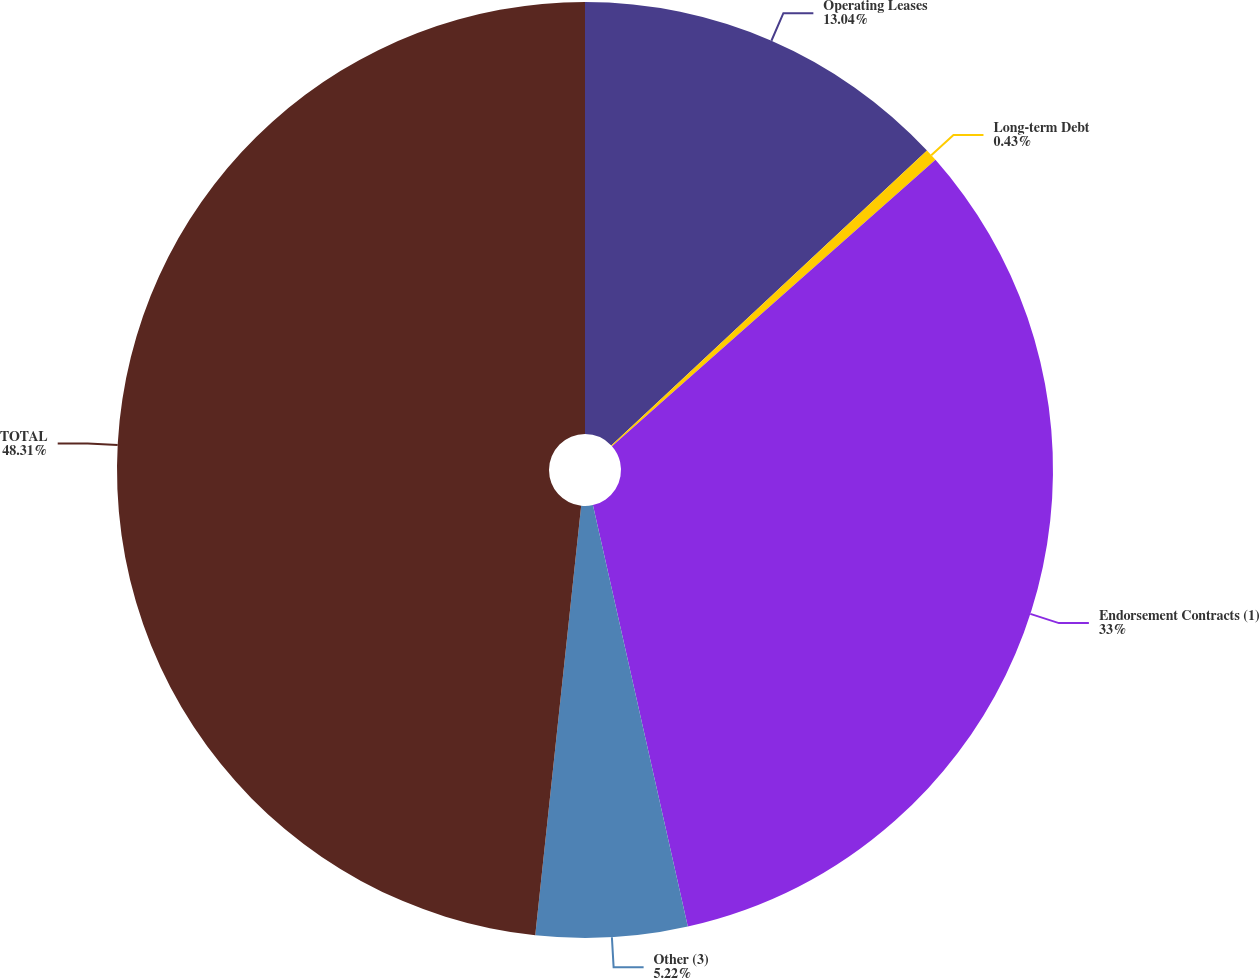Convert chart. <chart><loc_0><loc_0><loc_500><loc_500><pie_chart><fcel>Operating Leases<fcel>Long-term Debt<fcel>Endorsement Contracts (1)<fcel>Other (3)<fcel>TOTAL<nl><fcel>13.04%<fcel>0.43%<fcel>33.0%<fcel>5.22%<fcel>48.3%<nl></chart> 